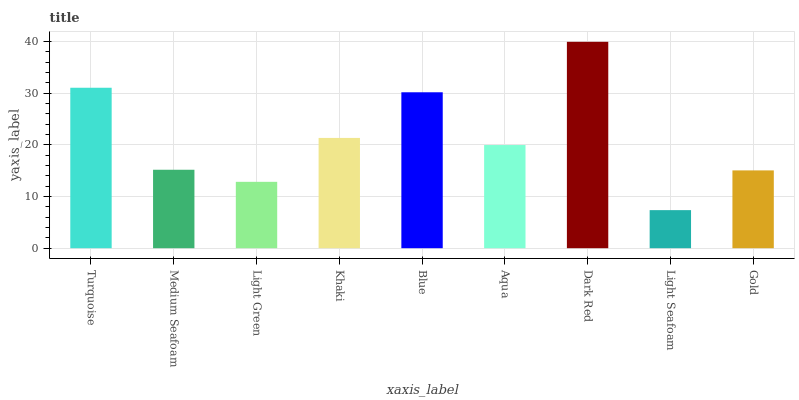Is Light Seafoam the minimum?
Answer yes or no. Yes. Is Dark Red the maximum?
Answer yes or no. Yes. Is Medium Seafoam the minimum?
Answer yes or no. No. Is Medium Seafoam the maximum?
Answer yes or no. No. Is Turquoise greater than Medium Seafoam?
Answer yes or no. Yes. Is Medium Seafoam less than Turquoise?
Answer yes or no. Yes. Is Medium Seafoam greater than Turquoise?
Answer yes or no. No. Is Turquoise less than Medium Seafoam?
Answer yes or no. No. Is Aqua the high median?
Answer yes or no. Yes. Is Aqua the low median?
Answer yes or no. Yes. Is Turquoise the high median?
Answer yes or no. No. Is Dark Red the low median?
Answer yes or no. No. 